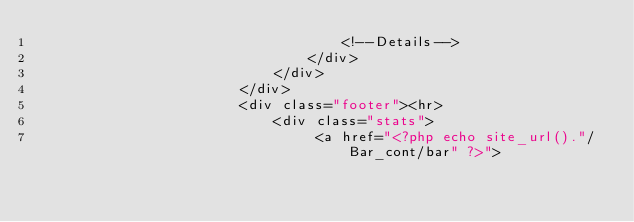<code> <loc_0><loc_0><loc_500><loc_500><_PHP_>                                    <!--Details-->
                                </div>
                            </div>
                        </div>
                        <div class="footer"><hr>
                            <div class="stats">
                                 <a href="<?php echo site_url()."/Bar_cont/bar" ?>"></code> 